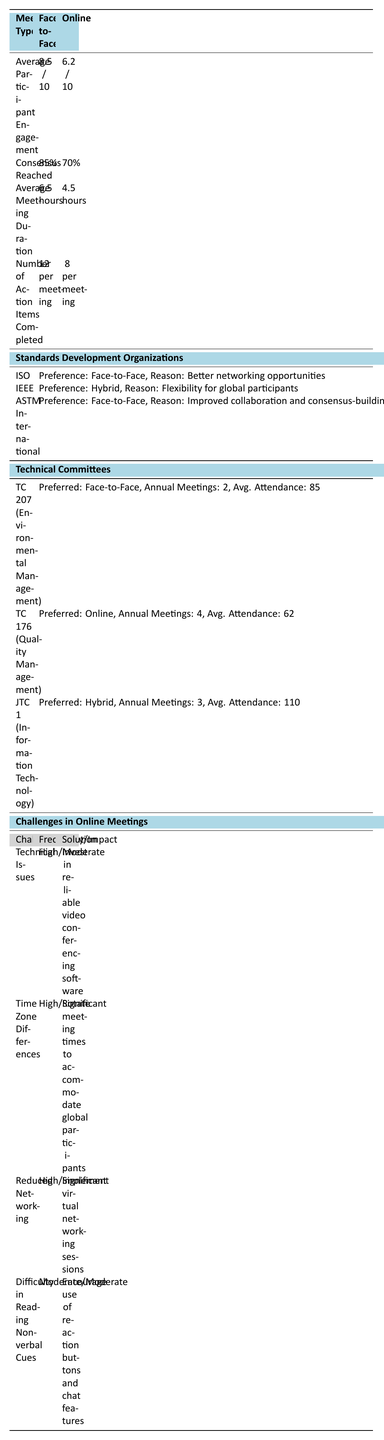What is the average participant engagement score for face-to-face meetings? The table states that the average participant engagement for face-to-face meetings is listed as 8.5 out of 10.
Answer: 8.5 out of 10 What percentage of consensus is reached in online meetings? The table shows that the consensus reached during online meetings is 70%.
Answer: 70% How much longer, on average, are face-to-face meetings compared to online meetings? The average duration for face-to-face meetings is 6.5 hours and for online meetings is 4.5 hours. The difference is 6.5 - 4.5 = 2 hours.
Answer: 2 hours What is the preference of ISO regarding meeting types? According to the table, ISO prefers face-to-face meetings due to better networking opportunities.
Answer: Face-to-Face Which technical committee prefers online meetings? The technology committee TC 176 (Quality Management) prefers online meetings as indicated in the table.
Answer: TC 176 (Quality Management) What is the total number of annual meetings between TC 207 and JTC 1? TC 207 has 2 annual meetings and JTC 1 has 3. Adding these together gives 2 + 3 = 5 annual meetings.
Answer: 5 What challenge has a high frequency and significant impact? Both "Time Zone Differences" and "Reduced Networking" are listed as having a high frequency and significant impact according to the table.
Answer: Yes, multiple challenges How many action items are completed on average per online meeting? The table states that on average, 8 action items are completed per online meeting.
Answer: 8 Which Standards Development Organization has a hybrid meeting preference? The table indicates that IEEE has a hybrid preference because it allows flexibility for global participants.
Answer: IEEE Are there more action items completed on average in face-to-face meetings compared to online meetings? The table shows that face-to-face meetings see 12 action items completed on average, while online meetings have 8. The greater number in face-to-face meetings indicates yes.
Answer: Yes How many total action items are completed across 4 online meetings? Each online meeting completes an average of 8 action items. So, across 4 meetings, the total is 8 * 4 = 32.
Answer: 32 